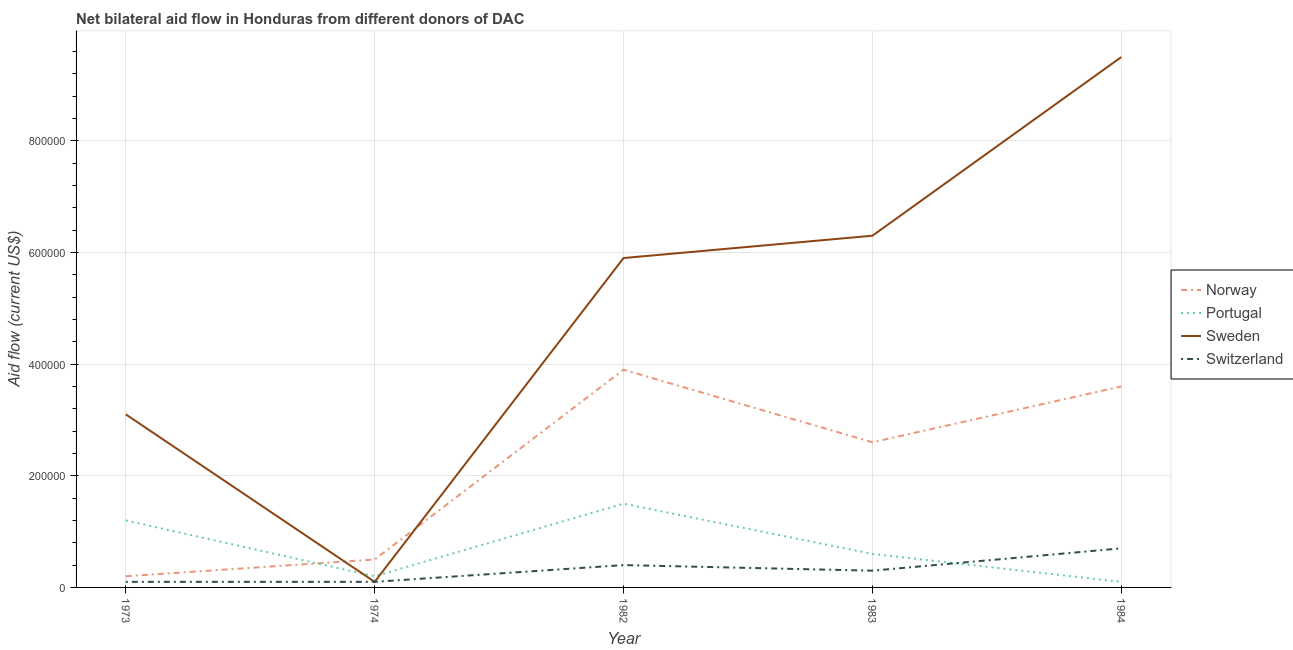What is the amount of aid given by portugal in 1973?
Ensure brevity in your answer.  1.20e+05. Across all years, what is the maximum amount of aid given by sweden?
Keep it short and to the point. 9.50e+05. Across all years, what is the minimum amount of aid given by norway?
Provide a succinct answer. 2.00e+04. What is the total amount of aid given by sweden in the graph?
Your answer should be very brief. 2.49e+06. What is the difference between the amount of aid given by norway in 1974 and that in 1984?
Make the answer very short. -3.10e+05. What is the difference between the amount of aid given by switzerland in 1984 and the amount of aid given by portugal in 1973?
Keep it short and to the point. -5.00e+04. What is the average amount of aid given by sweden per year?
Ensure brevity in your answer.  4.98e+05. In the year 1984, what is the difference between the amount of aid given by portugal and amount of aid given by sweden?
Your response must be concise. -9.40e+05. In how many years, is the amount of aid given by portugal greater than 680000 US$?
Your answer should be very brief. 0. What is the ratio of the amount of aid given by portugal in 1974 to that in 1984?
Give a very brief answer. 2. Is the amount of aid given by portugal in 1973 less than that in 1984?
Ensure brevity in your answer.  No. Is the difference between the amount of aid given by portugal in 1973 and 1982 greater than the difference between the amount of aid given by norway in 1973 and 1982?
Ensure brevity in your answer.  Yes. What is the difference between the highest and the second highest amount of aid given by sweden?
Provide a succinct answer. 3.20e+05. What is the difference between the highest and the lowest amount of aid given by norway?
Keep it short and to the point. 3.70e+05. Is it the case that in every year, the sum of the amount of aid given by norway and amount of aid given by portugal is greater than the amount of aid given by sweden?
Provide a succinct answer. No. Is the amount of aid given by switzerland strictly less than the amount of aid given by sweden over the years?
Keep it short and to the point. No. How many lines are there?
Your answer should be compact. 4. Are the values on the major ticks of Y-axis written in scientific E-notation?
Provide a short and direct response. No. Does the graph contain any zero values?
Ensure brevity in your answer.  No. Where does the legend appear in the graph?
Keep it short and to the point. Center right. How are the legend labels stacked?
Make the answer very short. Vertical. What is the title of the graph?
Your answer should be compact. Net bilateral aid flow in Honduras from different donors of DAC. Does "Public sector management" appear as one of the legend labels in the graph?
Your answer should be compact. No. What is the Aid flow (current US$) of Norway in 1973?
Give a very brief answer. 2.00e+04. What is the Aid flow (current US$) of Switzerland in 1973?
Offer a very short reply. 10000. What is the Aid flow (current US$) in Portugal in 1974?
Make the answer very short. 2.00e+04. What is the Aid flow (current US$) in Sweden in 1974?
Provide a short and direct response. 10000. What is the Aid flow (current US$) in Switzerland in 1974?
Keep it short and to the point. 10000. What is the Aid flow (current US$) in Norway in 1982?
Make the answer very short. 3.90e+05. What is the Aid flow (current US$) in Portugal in 1982?
Your answer should be compact. 1.50e+05. What is the Aid flow (current US$) of Sweden in 1982?
Your response must be concise. 5.90e+05. What is the Aid flow (current US$) of Portugal in 1983?
Your answer should be very brief. 6.00e+04. What is the Aid flow (current US$) in Sweden in 1983?
Your answer should be compact. 6.30e+05. What is the Aid flow (current US$) in Switzerland in 1983?
Offer a very short reply. 3.00e+04. What is the Aid flow (current US$) of Norway in 1984?
Keep it short and to the point. 3.60e+05. What is the Aid flow (current US$) of Portugal in 1984?
Offer a terse response. 10000. What is the Aid flow (current US$) of Sweden in 1984?
Offer a very short reply. 9.50e+05. Across all years, what is the maximum Aid flow (current US$) of Norway?
Your response must be concise. 3.90e+05. Across all years, what is the maximum Aid flow (current US$) of Portugal?
Your answer should be compact. 1.50e+05. Across all years, what is the maximum Aid flow (current US$) of Sweden?
Offer a terse response. 9.50e+05. Across all years, what is the maximum Aid flow (current US$) of Switzerland?
Your response must be concise. 7.00e+04. Across all years, what is the minimum Aid flow (current US$) in Sweden?
Make the answer very short. 10000. What is the total Aid flow (current US$) in Norway in the graph?
Make the answer very short. 1.08e+06. What is the total Aid flow (current US$) of Portugal in the graph?
Offer a terse response. 3.60e+05. What is the total Aid flow (current US$) of Sweden in the graph?
Give a very brief answer. 2.49e+06. What is the difference between the Aid flow (current US$) of Portugal in 1973 and that in 1974?
Your answer should be very brief. 1.00e+05. What is the difference between the Aid flow (current US$) of Switzerland in 1973 and that in 1974?
Your response must be concise. 0. What is the difference between the Aid flow (current US$) in Norway in 1973 and that in 1982?
Provide a succinct answer. -3.70e+05. What is the difference between the Aid flow (current US$) in Portugal in 1973 and that in 1982?
Ensure brevity in your answer.  -3.00e+04. What is the difference between the Aid flow (current US$) of Sweden in 1973 and that in 1982?
Offer a terse response. -2.80e+05. What is the difference between the Aid flow (current US$) in Switzerland in 1973 and that in 1982?
Make the answer very short. -3.00e+04. What is the difference between the Aid flow (current US$) in Sweden in 1973 and that in 1983?
Offer a terse response. -3.20e+05. What is the difference between the Aid flow (current US$) in Portugal in 1973 and that in 1984?
Provide a short and direct response. 1.10e+05. What is the difference between the Aid flow (current US$) in Sweden in 1973 and that in 1984?
Provide a short and direct response. -6.40e+05. What is the difference between the Aid flow (current US$) in Norway in 1974 and that in 1982?
Your response must be concise. -3.40e+05. What is the difference between the Aid flow (current US$) in Sweden in 1974 and that in 1982?
Your response must be concise. -5.80e+05. What is the difference between the Aid flow (current US$) of Switzerland in 1974 and that in 1982?
Ensure brevity in your answer.  -3.00e+04. What is the difference between the Aid flow (current US$) in Norway in 1974 and that in 1983?
Offer a very short reply. -2.10e+05. What is the difference between the Aid flow (current US$) in Portugal in 1974 and that in 1983?
Offer a terse response. -4.00e+04. What is the difference between the Aid flow (current US$) of Sweden in 1974 and that in 1983?
Your answer should be compact. -6.20e+05. What is the difference between the Aid flow (current US$) in Norway in 1974 and that in 1984?
Make the answer very short. -3.10e+05. What is the difference between the Aid flow (current US$) of Sweden in 1974 and that in 1984?
Offer a terse response. -9.40e+05. What is the difference between the Aid flow (current US$) in Norway in 1982 and that in 1983?
Provide a short and direct response. 1.30e+05. What is the difference between the Aid flow (current US$) in Portugal in 1982 and that in 1983?
Provide a succinct answer. 9.00e+04. What is the difference between the Aid flow (current US$) in Sweden in 1982 and that in 1983?
Offer a very short reply. -4.00e+04. What is the difference between the Aid flow (current US$) in Switzerland in 1982 and that in 1983?
Make the answer very short. 10000. What is the difference between the Aid flow (current US$) of Norway in 1982 and that in 1984?
Give a very brief answer. 3.00e+04. What is the difference between the Aid flow (current US$) in Portugal in 1982 and that in 1984?
Offer a terse response. 1.40e+05. What is the difference between the Aid flow (current US$) of Sweden in 1982 and that in 1984?
Provide a short and direct response. -3.60e+05. What is the difference between the Aid flow (current US$) in Switzerland in 1982 and that in 1984?
Make the answer very short. -3.00e+04. What is the difference between the Aid flow (current US$) of Portugal in 1983 and that in 1984?
Provide a short and direct response. 5.00e+04. What is the difference between the Aid flow (current US$) in Sweden in 1983 and that in 1984?
Your response must be concise. -3.20e+05. What is the difference between the Aid flow (current US$) of Switzerland in 1983 and that in 1984?
Provide a short and direct response. -4.00e+04. What is the difference between the Aid flow (current US$) in Norway in 1973 and the Aid flow (current US$) in Switzerland in 1974?
Provide a succinct answer. 10000. What is the difference between the Aid flow (current US$) of Norway in 1973 and the Aid flow (current US$) of Portugal in 1982?
Keep it short and to the point. -1.30e+05. What is the difference between the Aid flow (current US$) in Norway in 1973 and the Aid flow (current US$) in Sweden in 1982?
Give a very brief answer. -5.70e+05. What is the difference between the Aid flow (current US$) of Norway in 1973 and the Aid flow (current US$) of Switzerland in 1982?
Offer a very short reply. -2.00e+04. What is the difference between the Aid flow (current US$) of Portugal in 1973 and the Aid flow (current US$) of Sweden in 1982?
Your response must be concise. -4.70e+05. What is the difference between the Aid flow (current US$) of Portugal in 1973 and the Aid flow (current US$) of Switzerland in 1982?
Provide a short and direct response. 8.00e+04. What is the difference between the Aid flow (current US$) of Norway in 1973 and the Aid flow (current US$) of Sweden in 1983?
Your answer should be very brief. -6.10e+05. What is the difference between the Aid flow (current US$) in Norway in 1973 and the Aid flow (current US$) in Switzerland in 1983?
Provide a short and direct response. -10000. What is the difference between the Aid flow (current US$) of Portugal in 1973 and the Aid flow (current US$) of Sweden in 1983?
Your answer should be very brief. -5.10e+05. What is the difference between the Aid flow (current US$) in Portugal in 1973 and the Aid flow (current US$) in Switzerland in 1983?
Your answer should be very brief. 9.00e+04. What is the difference between the Aid flow (current US$) in Sweden in 1973 and the Aid flow (current US$) in Switzerland in 1983?
Keep it short and to the point. 2.80e+05. What is the difference between the Aid flow (current US$) in Norway in 1973 and the Aid flow (current US$) in Sweden in 1984?
Your response must be concise. -9.30e+05. What is the difference between the Aid flow (current US$) in Portugal in 1973 and the Aid flow (current US$) in Sweden in 1984?
Your answer should be very brief. -8.30e+05. What is the difference between the Aid flow (current US$) in Sweden in 1973 and the Aid flow (current US$) in Switzerland in 1984?
Ensure brevity in your answer.  2.40e+05. What is the difference between the Aid flow (current US$) in Norway in 1974 and the Aid flow (current US$) in Portugal in 1982?
Provide a short and direct response. -1.00e+05. What is the difference between the Aid flow (current US$) of Norway in 1974 and the Aid flow (current US$) of Sweden in 1982?
Provide a short and direct response. -5.40e+05. What is the difference between the Aid flow (current US$) in Portugal in 1974 and the Aid flow (current US$) in Sweden in 1982?
Give a very brief answer. -5.70e+05. What is the difference between the Aid flow (current US$) in Portugal in 1974 and the Aid flow (current US$) in Switzerland in 1982?
Make the answer very short. -2.00e+04. What is the difference between the Aid flow (current US$) in Norway in 1974 and the Aid flow (current US$) in Portugal in 1983?
Provide a succinct answer. -10000. What is the difference between the Aid flow (current US$) of Norway in 1974 and the Aid flow (current US$) of Sweden in 1983?
Your answer should be very brief. -5.80e+05. What is the difference between the Aid flow (current US$) in Norway in 1974 and the Aid flow (current US$) in Switzerland in 1983?
Offer a very short reply. 2.00e+04. What is the difference between the Aid flow (current US$) of Portugal in 1974 and the Aid flow (current US$) of Sweden in 1983?
Your response must be concise. -6.10e+05. What is the difference between the Aid flow (current US$) of Portugal in 1974 and the Aid flow (current US$) of Switzerland in 1983?
Your response must be concise. -10000. What is the difference between the Aid flow (current US$) of Sweden in 1974 and the Aid flow (current US$) of Switzerland in 1983?
Offer a terse response. -2.00e+04. What is the difference between the Aid flow (current US$) in Norway in 1974 and the Aid flow (current US$) in Sweden in 1984?
Your response must be concise. -9.00e+05. What is the difference between the Aid flow (current US$) of Portugal in 1974 and the Aid flow (current US$) of Sweden in 1984?
Give a very brief answer. -9.30e+05. What is the difference between the Aid flow (current US$) in Sweden in 1974 and the Aid flow (current US$) in Switzerland in 1984?
Offer a terse response. -6.00e+04. What is the difference between the Aid flow (current US$) of Portugal in 1982 and the Aid flow (current US$) of Sweden in 1983?
Ensure brevity in your answer.  -4.80e+05. What is the difference between the Aid flow (current US$) of Portugal in 1982 and the Aid flow (current US$) of Switzerland in 1983?
Your answer should be very brief. 1.20e+05. What is the difference between the Aid flow (current US$) of Sweden in 1982 and the Aid flow (current US$) of Switzerland in 1983?
Your answer should be very brief. 5.60e+05. What is the difference between the Aid flow (current US$) in Norway in 1982 and the Aid flow (current US$) in Portugal in 1984?
Give a very brief answer. 3.80e+05. What is the difference between the Aid flow (current US$) in Norway in 1982 and the Aid flow (current US$) in Sweden in 1984?
Your answer should be very brief. -5.60e+05. What is the difference between the Aid flow (current US$) in Norway in 1982 and the Aid flow (current US$) in Switzerland in 1984?
Give a very brief answer. 3.20e+05. What is the difference between the Aid flow (current US$) in Portugal in 1982 and the Aid flow (current US$) in Sweden in 1984?
Offer a terse response. -8.00e+05. What is the difference between the Aid flow (current US$) in Sweden in 1982 and the Aid flow (current US$) in Switzerland in 1984?
Give a very brief answer. 5.20e+05. What is the difference between the Aid flow (current US$) of Norway in 1983 and the Aid flow (current US$) of Sweden in 1984?
Keep it short and to the point. -6.90e+05. What is the difference between the Aid flow (current US$) in Norway in 1983 and the Aid flow (current US$) in Switzerland in 1984?
Provide a short and direct response. 1.90e+05. What is the difference between the Aid flow (current US$) of Portugal in 1983 and the Aid flow (current US$) of Sweden in 1984?
Your response must be concise. -8.90e+05. What is the difference between the Aid flow (current US$) in Portugal in 1983 and the Aid flow (current US$) in Switzerland in 1984?
Offer a terse response. -10000. What is the difference between the Aid flow (current US$) in Sweden in 1983 and the Aid flow (current US$) in Switzerland in 1984?
Your answer should be compact. 5.60e+05. What is the average Aid flow (current US$) in Norway per year?
Ensure brevity in your answer.  2.16e+05. What is the average Aid flow (current US$) in Portugal per year?
Offer a terse response. 7.20e+04. What is the average Aid flow (current US$) of Sweden per year?
Ensure brevity in your answer.  4.98e+05. What is the average Aid flow (current US$) in Switzerland per year?
Keep it short and to the point. 3.20e+04. In the year 1973, what is the difference between the Aid flow (current US$) of Norway and Aid flow (current US$) of Sweden?
Keep it short and to the point. -2.90e+05. In the year 1973, what is the difference between the Aid flow (current US$) in Norway and Aid flow (current US$) in Switzerland?
Provide a succinct answer. 10000. In the year 1973, what is the difference between the Aid flow (current US$) in Portugal and Aid flow (current US$) in Switzerland?
Offer a very short reply. 1.10e+05. In the year 1973, what is the difference between the Aid flow (current US$) of Sweden and Aid flow (current US$) of Switzerland?
Provide a short and direct response. 3.00e+05. In the year 1974, what is the difference between the Aid flow (current US$) in Norway and Aid flow (current US$) in Switzerland?
Your answer should be compact. 4.00e+04. In the year 1982, what is the difference between the Aid flow (current US$) of Portugal and Aid flow (current US$) of Sweden?
Offer a terse response. -4.40e+05. In the year 1983, what is the difference between the Aid flow (current US$) in Norway and Aid flow (current US$) in Portugal?
Offer a very short reply. 2.00e+05. In the year 1983, what is the difference between the Aid flow (current US$) of Norway and Aid flow (current US$) of Sweden?
Your answer should be compact. -3.70e+05. In the year 1983, what is the difference between the Aid flow (current US$) of Portugal and Aid flow (current US$) of Sweden?
Make the answer very short. -5.70e+05. In the year 1984, what is the difference between the Aid flow (current US$) of Norway and Aid flow (current US$) of Portugal?
Offer a very short reply. 3.50e+05. In the year 1984, what is the difference between the Aid flow (current US$) of Norway and Aid flow (current US$) of Sweden?
Provide a succinct answer. -5.90e+05. In the year 1984, what is the difference between the Aid flow (current US$) of Norway and Aid flow (current US$) of Switzerland?
Keep it short and to the point. 2.90e+05. In the year 1984, what is the difference between the Aid flow (current US$) in Portugal and Aid flow (current US$) in Sweden?
Your response must be concise. -9.40e+05. In the year 1984, what is the difference between the Aid flow (current US$) of Portugal and Aid flow (current US$) of Switzerland?
Your answer should be compact. -6.00e+04. In the year 1984, what is the difference between the Aid flow (current US$) in Sweden and Aid flow (current US$) in Switzerland?
Your answer should be very brief. 8.80e+05. What is the ratio of the Aid flow (current US$) in Norway in 1973 to that in 1974?
Your response must be concise. 0.4. What is the ratio of the Aid flow (current US$) in Portugal in 1973 to that in 1974?
Offer a very short reply. 6. What is the ratio of the Aid flow (current US$) of Switzerland in 1973 to that in 1974?
Offer a terse response. 1. What is the ratio of the Aid flow (current US$) in Norway in 1973 to that in 1982?
Your answer should be compact. 0.05. What is the ratio of the Aid flow (current US$) in Portugal in 1973 to that in 1982?
Your answer should be compact. 0.8. What is the ratio of the Aid flow (current US$) in Sweden in 1973 to that in 1982?
Your answer should be very brief. 0.53. What is the ratio of the Aid flow (current US$) of Switzerland in 1973 to that in 1982?
Your answer should be compact. 0.25. What is the ratio of the Aid flow (current US$) of Norway in 1973 to that in 1983?
Provide a succinct answer. 0.08. What is the ratio of the Aid flow (current US$) of Portugal in 1973 to that in 1983?
Ensure brevity in your answer.  2. What is the ratio of the Aid flow (current US$) of Sweden in 1973 to that in 1983?
Offer a very short reply. 0.49. What is the ratio of the Aid flow (current US$) in Norway in 1973 to that in 1984?
Offer a very short reply. 0.06. What is the ratio of the Aid flow (current US$) of Portugal in 1973 to that in 1984?
Provide a succinct answer. 12. What is the ratio of the Aid flow (current US$) in Sweden in 1973 to that in 1984?
Offer a very short reply. 0.33. What is the ratio of the Aid flow (current US$) in Switzerland in 1973 to that in 1984?
Offer a very short reply. 0.14. What is the ratio of the Aid flow (current US$) in Norway in 1974 to that in 1982?
Keep it short and to the point. 0.13. What is the ratio of the Aid flow (current US$) of Portugal in 1974 to that in 1982?
Make the answer very short. 0.13. What is the ratio of the Aid flow (current US$) of Sweden in 1974 to that in 1982?
Make the answer very short. 0.02. What is the ratio of the Aid flow (current US$) of Switzerland in 1974 to that in 1982?
Your response must be concise. 0.25. What is the ratio of the Aid flow (current US$) in Norway in 1974 to that in 1983?
Your answer should be compact. 0.19. What is the ratio of the Aid flow (current US$) of Sweden in 1974 to that in 1983?
Offer a terse response. 0.02. What is the ratio of the Aid flow (current US$) in Norway in 1974 to that in 1984?
Give a very brief answer. 0.14. What is the ratio of the Aid flow (current US$) in Portugal in 1974 to that in 1984?
Keep it short and to the point. 2. What is the ratio of the Aid flow (current US$) of Sweden in 1974 to that in 1984?
Provide a short and direct response. 0.01. What is the ratio of the Aid flow (current US$) in Switzerland in 1974 to that in 1984?
Ensure brevity in your answer.  0.14. What is the ratio of the Aid flow (current US$) of Sweden in 1982 to that in 1983?
Your answer should be compact. 0.94. What is the ratio of the Aid flow (current US$) in Switzerland in 1982 to that in 1983?
Your answer should be very brief. 1.33. What is the ratio of the Aid flow (current US$) of Portugal in 1982 to that in 1984?
Offer a terse response. 15. What is the ratio of the Aid flow (current US$) of Sweden in 1982 to that in 1984?
Offer a very short reply. 0.62. What is the ratio of the Aid flow (current US$) of Switzerland in 1982 to that in 1984?
Your response must be concise. 0.57. What is the ratio of the Aid flow (current US$) of Norway in 1983 to that in 1984?
Your response must be concise. 0.72. What is the ratio of the Aid flow (current US$) in Sweden in 1983 to that in 1984?
Keep it short and to the point. 0.66. What is the ratio of the Aid flow (current US$) of Switzerland in 1983 to that in 1984?
Offer a very short reply. 0.43. What is the difference between the highest and the second highest Aid flow (current US$) of Switzerland?
Your response must be concise. 3.00e+04. What is the difference between the highest and the lowest Aid flow (current US$) of Norway?
Keep it short and to the point. 3.70e+05. What is the difference between the highest and the lowest Aid flow (current US$) in Portugal?
Keep it short and to the point. 1.40e+05. What is the difference between the highest and the lowest Aid flow (current US$) of Sweden?
Offer a very short reply. 9.40e+05. 